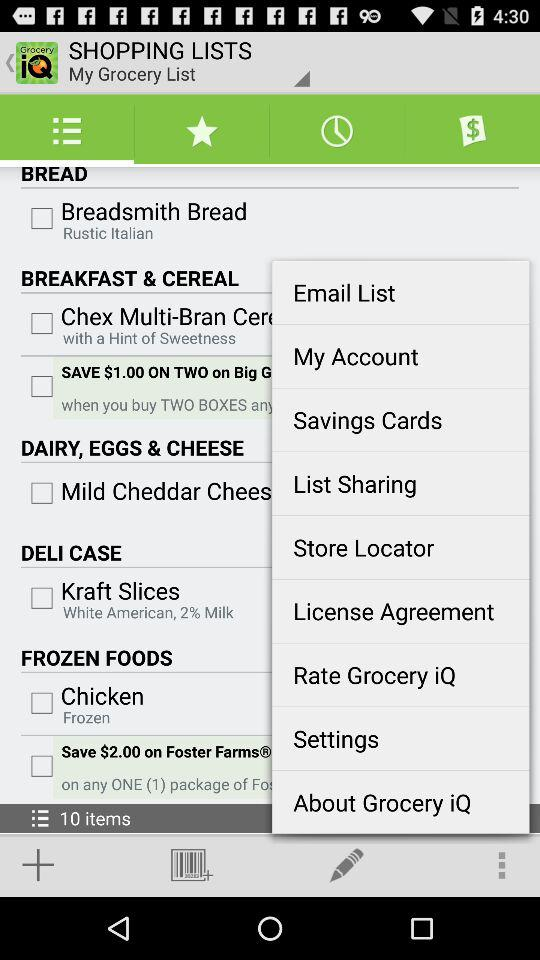What is the type of "Kraft Slices"? The type is "White American". 